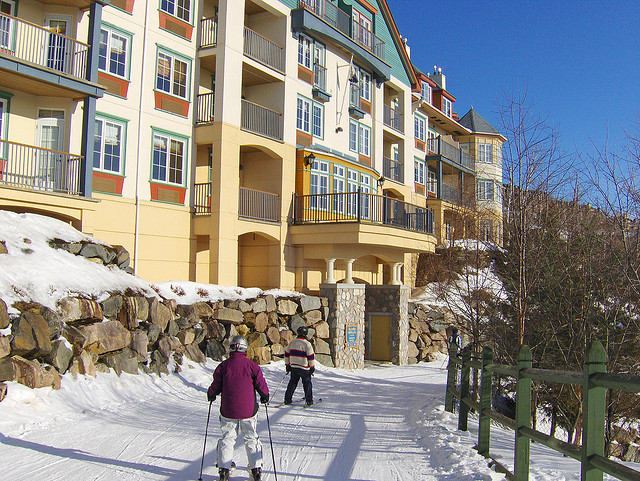What activity are the people in the image doing? The two individuals in the image are engaged in cross-country skiing, which is a popular winter activity that involves traversing over snow-covered terrain using skis. Is cross-country skiing a good form of exercise? Yes, cross-country skiing is an excellent form of exercise. It provides a full-body workout, improves cardiovascular health, and can burn a significant number of calories. 